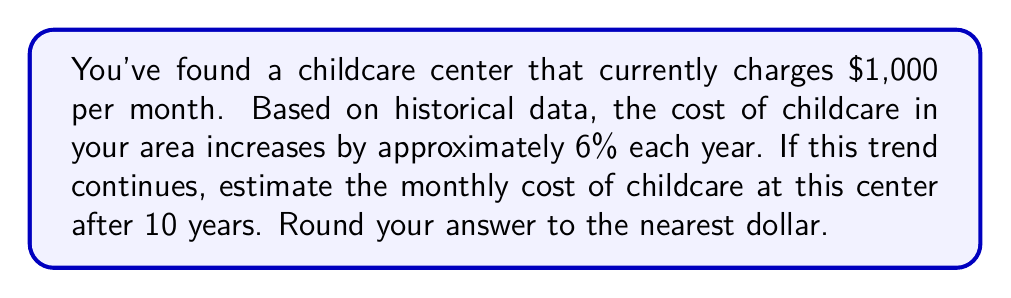Give your solution to this math problem. Let's approach this step-by-step:

1) We can model this situation using an exponential function:
   $A = P(1 + r)^t$
   Where:
   $A$ = final amount
   $P$ = initial principal balance
   $r$ = annual rate (in decimal form)
   $t$ = number of years

2) We know:
   $P = 1000$ (initial monthly cost)
   $r = 0.06$ (6% annual increase)
   $t = 10$ years

3) Let's plug these values into our equation:
   $A = 1000(1 + 0.06)^{10}$

4) Simplify inside the parentheses:
   $A = 1000(1.06)^{10}$

5) Calculate the exponent:
   $(1.06)^{10} \approx 1.7908$

6) Multiply:
   $A = 1000 * 1.7908 = 1790.80$

7) Rounding to the nearest dollar:
   $A \approx 1791$

Therefore, after 10 years, the estimated monthly cost of childcare will be $1,791.
Answer: $1,791 